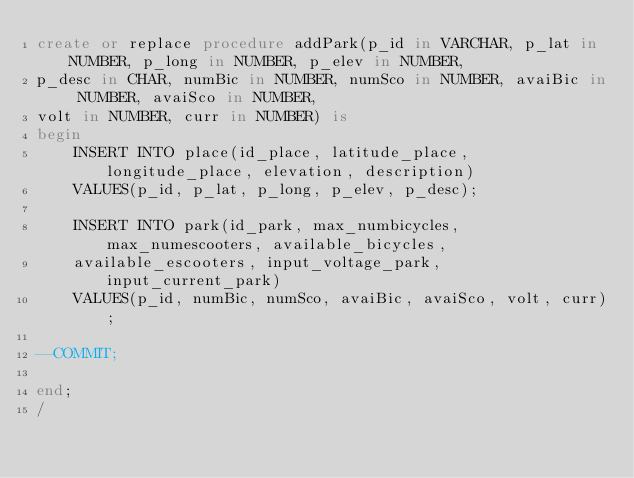Convert code to text. <code><loc_0><loc_0><loc_500><loc_500><_SQL_>create or replace procedure addPark(p_id in VARCHAR, p_lat in NUMBER, p_long in NUMBER, p_elev in NUMBER, 
p_desc in CHAR, numBic in NUMBER, numSco in NUMBER, avaiBic in NUMBER, avaiSco in NUMBER, 
volt in NUMBER, curr in NUMBER) is
begin
    INSERT INTO place(id_place, latitude_place, longitude_place, elevation, description)
    VALUES(p_id, p_lat, p_long, p_elev, p_desc);
    
    INSERT INTO park(id_park, max_numbicycles, max_numescooters, available_bicycles, 
    available_escooters, input_voltage_park, input_current_park)
    VALUES(p_id, numBic, numSco, avaiBic, avaiSco, volt, curr);

--COMMIT;

end;
/
</code> 